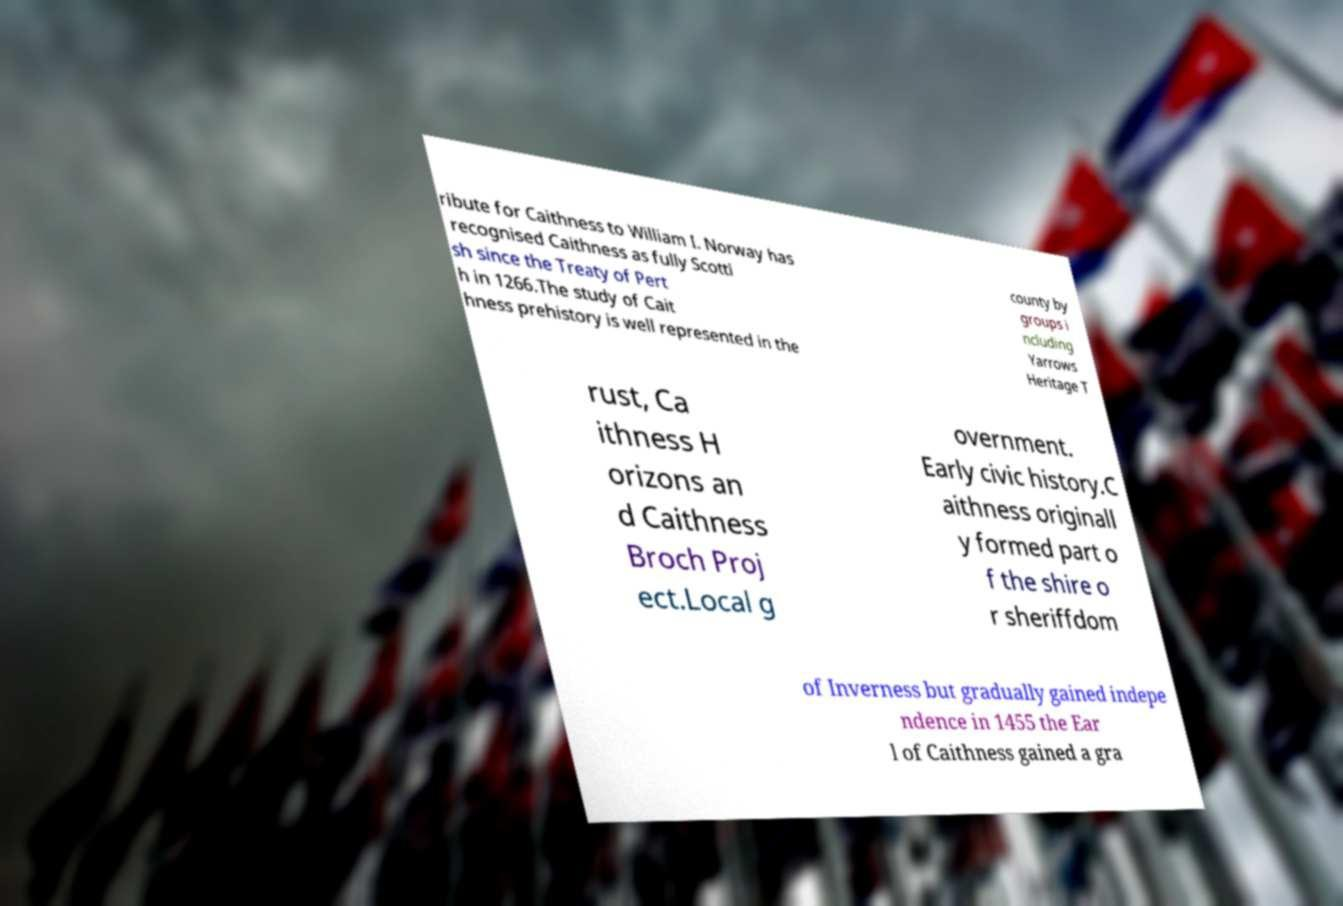Can you read and provide the text displayed in the image?This photo seems to have some interesting text. Can you extract and type it out for me? ribute for Caithness to William I. Norway has recognised Caithness as fully Scotti sh since the Treaty of Pert h in 1266.The study of Cait hness prehistory is well represented in the county by groups i ncluding Yarrows Heritage T rust, Ca ithness H orizons an d Caithness Broch Proj ect.Local g overnment. Early civic history.C aithness originall y formed part o f the shire o r sheriffdom of Inverness but gradually gained indepe ndence in 1455 the Ear l of Caithness gained a gra 